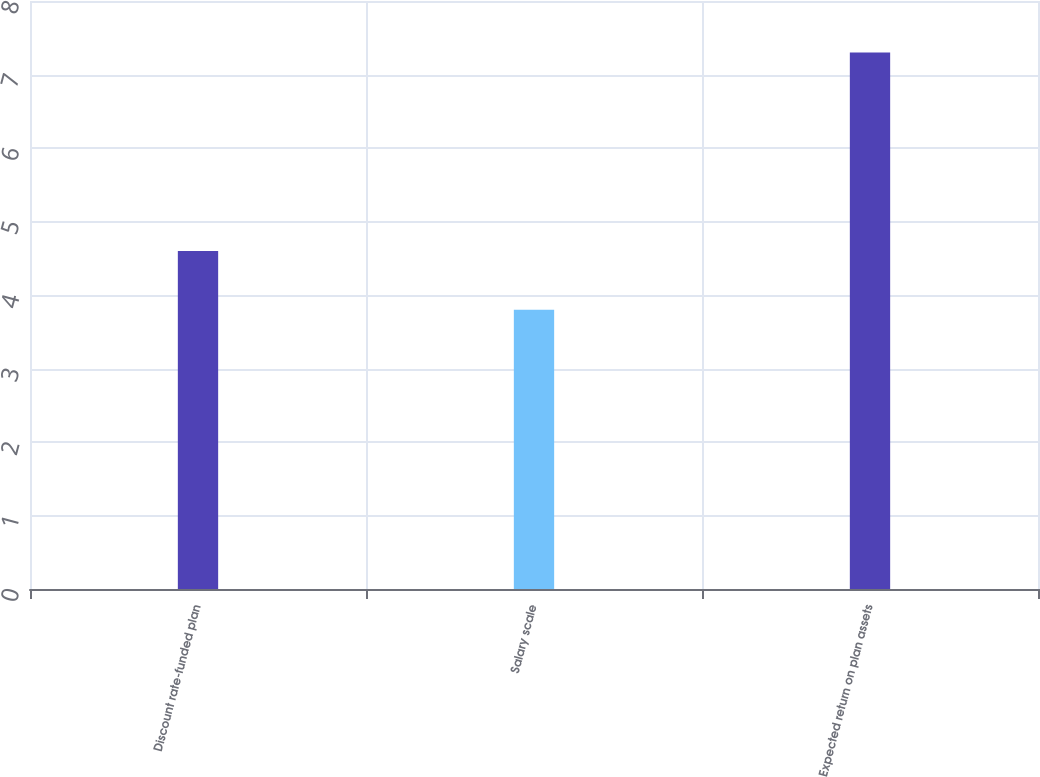Convert chart. <chart><loc_0><loc_0><loc_500><loc_500><bar_chart><fcel>Discount rate-funded plan<fcel>Salary scale<fcel>Expected return on plan assets<nl><fcel>4.6<fcel>3.8<fcel>7.3<nl></chart> 